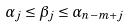<formula> <loc_0><loc_0><loc_500><loc_500>\alpha _ { j } \leq \beta _ { j } \leq \alpha _ { n - m + j }</formula> 